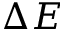<formula> <loc_0><loc_0><loc_500><loc_500>\Delta E</formula> 